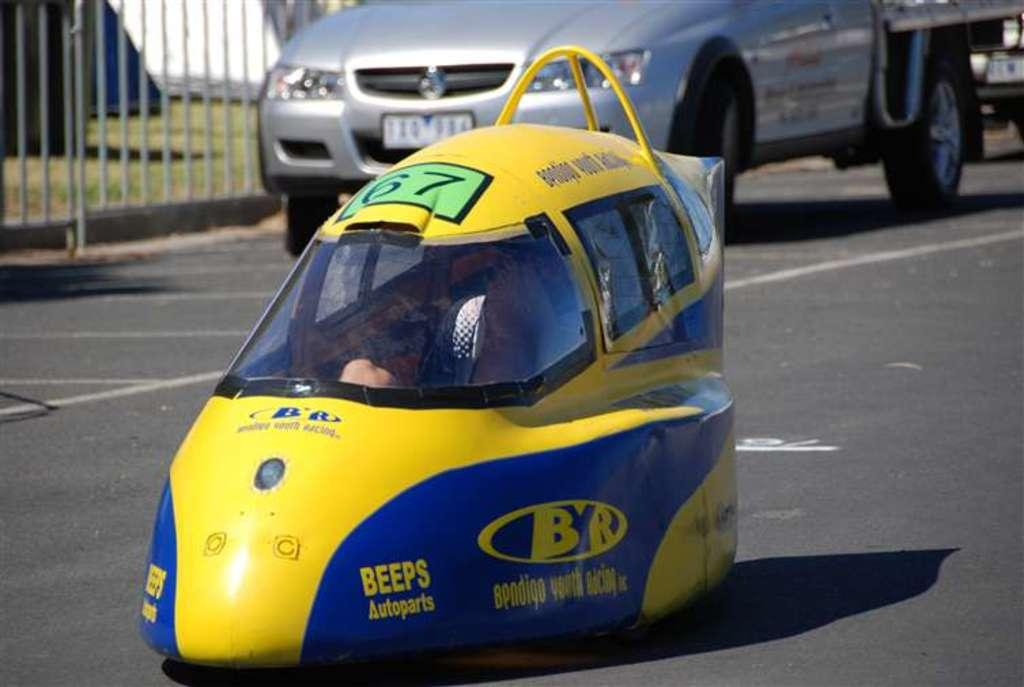Provide a one-sentence caption for the provided image. a vehicle in the road that is super small with BEEPS Autoparts Bendigo Youth Racing on it. 